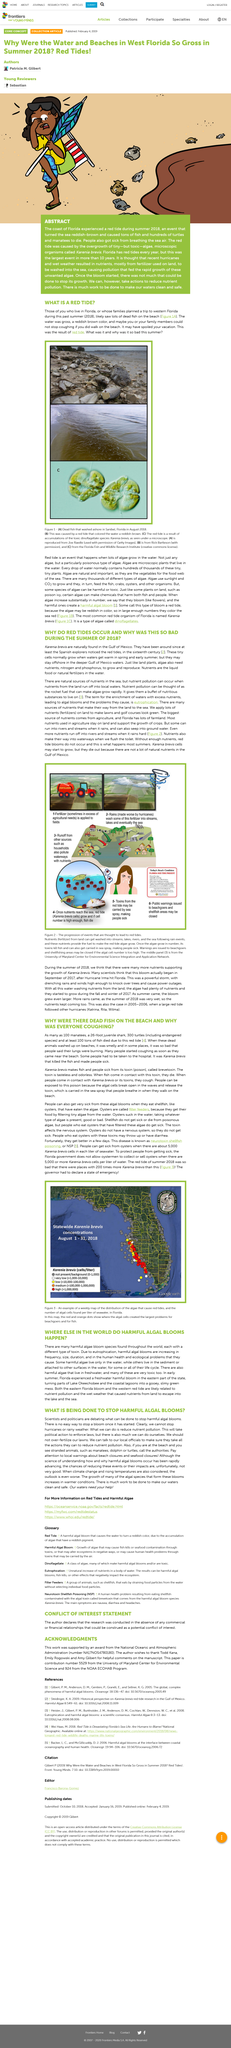Indicate a few pertinent items in this graphic. The increase in frequency, size, and duration of algal blooms is primarily due to eutrophication. Karenia brevis is primarily found in the Gulf of Mexico. The article mentions that the red tides were particularly severe in 2018. The color of the ocean was reddish-brown. Harmful algal blooms occur in various regions around the world, with a diverse range of algal species contributing to their occurrence. 